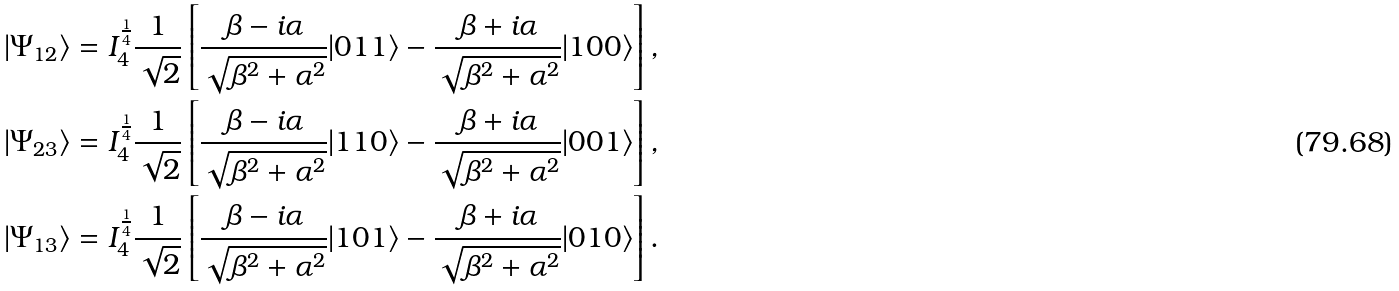Convert formula to latex. <formula><loc_0><loc_0><loc_500><loc_500>| \Psi _ { 1 2 } \rangle & = I _ { 4 } ^ { \frac { 1 } { 4 } } \frac { 1 } { \sqrt { 2 } } \left [ \frac { \beta - i \alpha } { \sqrt { \beta ^ { 2 } + \alpha ^ { 2 } } } | 0 1 1 \rangle - \frac { \beta + i \alpha } { \sqrt { \beta ^ { 2 } + \alpha ^ { 2 } } } | 1 0 0 \rangle \right ] , \\ | \Psi _ { 2 3 } \rangle & = I _ { 4 } ^ { \frac { 1 } { 4 } } \frac { 1 } { \sqrt { 2 } } \left [ \frac { \beta - i \alpha } { \sqrt { \beta ^ { 2 } + \alpha ^ { 2 } } } | 1 1 0 \rangle - \frac { \beta + i \alpha } { \sqrt { \beta ^ { 2 } + \alpha ^ { 2 } } } | 0 0 1 \rangle \right ] , \\ | \Psi _ { 1 3 } \rangle & = I _ { 4 } ^ { \frac { 1 } { 4 } } \frac { 1 } { \sqrt { 2 } } \left [ \frac { \beta - i \alpha } { \sqrt { \beta ^ { 2 } + \alpha ^ { 2 } } } | 1 0 1 \rangle - \frac { \beta + i \alpha } { \sqrt { \beta ^ { 2 } + \alpha ^ { 2 } } } | 0 1 0 \rangle \right ] .</formula> 